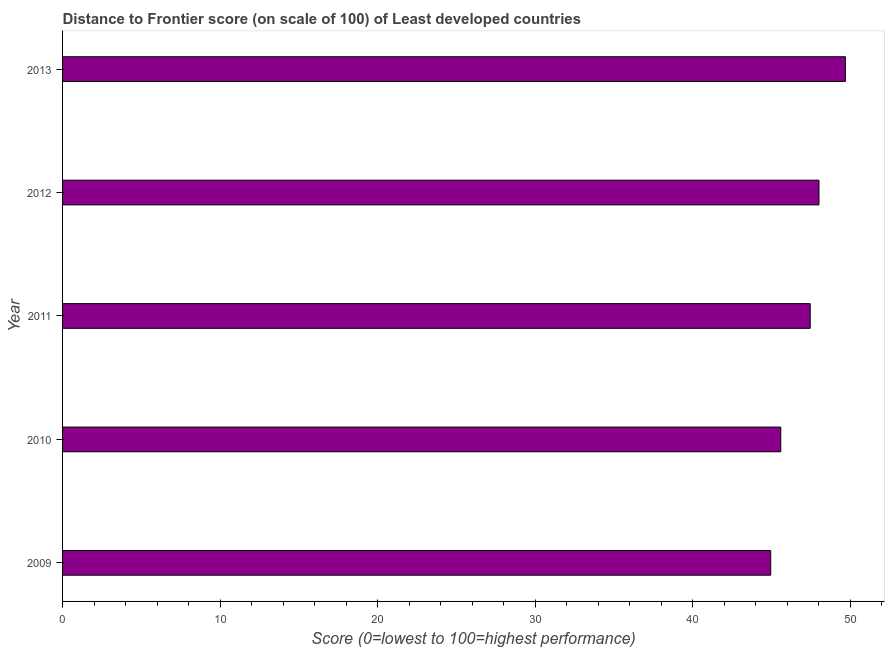Does the graph contain any zero values?
Your answer should be very brief. No. What is the title of the graph?
Offer a very short reply. Distance to Frontier score (on scale of 100) of Least developed countries. What is the label or title of the X-axis?
Your answer should be very brief. Score (0=lowest to 100=highest performance). What is the label or title of the Y-axis?
Keep it short and to the point. Year. What is the distance to frontier score in 2013?
Give a very brief answer. 49.7. Across all years, what is the maximum distance to frontier score?
Ensure brevity in your answer.  49.7. Across all years, what is the minimum distance to frontier score?
Your answer should be very brief. 44.96. In which year was the distance to frontier score maximum?
Provide a succinct answer. 2013. What is the sum of the distance to frontier score?
Your answer should be very brief. 235.77. What is the difference between the distance to frontier score in 2010 and 2011?
Make the answer very short. -1.87. What is the average distance to frontier score per year?
Give a very brief answer. 47.15. What is the median distance to frontier score?
Provide a succinct answer. 47.47. In how many years, is the distance to frontier score greater than 18 ?
Offer a very short reply. 5. Is the difference between the distance to frontier score in 2009 and 2012 greater than the difference between any two years?
Offer a very short reply. No. What is the difference between the highest and the second highest distance to frontier score?
Keep it short and to the point. 1.68. Is the sum of the distance to frontier score in 2010 and 2011 greater than the maximum distance to frontier score across all years?
Provide a succinct answer. Yes. What is the difference between the highest and the lowest distance to frontier score?
Offer a very short reply. 4.74. How many bars are there?
Provide a short and direct response. 5. Are all the bars in the graph horizontal?
Provide a succinct answer. Yes. How many years are there in the graph?
Your answer should be very brief. 5. What is the Score (0=lowest to 100=highest performance) of 2009?
Ensure brevity in your answer.  44.96. What is the Score (0=lowest to 100=highest performance) in 2010?
Your response must be concise. 45.6. What is the Score (0=lowest to 100=highest performance) of 2011?
Make the answer very short. 47.47. What is the Score (0=lowest to 100=highest performance) of 2012?
Provide a succinct answer. 48.03. What is the Score (0=lowest to 100=highest performance) of 2013?
Give a very brief answer. 49.7. What is the difference between the Score (0=lowest to 100=highest performance) in 2009 and 2010?
Keep it short and to the point. -0.64. What is the difference between the Score (0=lowest to 100=highest performance) in 2009 and 2011?
Give a very brief answer. -2.51. What is the difference between the Score (0=lowest to 100=highest performance) in 2009 and 2012?
Give a very brief answer. -3.06. What is the difference between the Score (0=lowest to 100=highest performance) in 2009 and 2013?
Offer a very short reply. -4.74. What is the difference between the Score (0=lowest to 100=highest performance) in 2010 and 2011?
Your answer should be very brief. -1.87. What is the difference between the Score (0=lowest to 100=highest performance) in 2010 and 2012?
Provide a short and direct response. -2.43. What is the difference between the Score (0=lowest to 100=highest performance) in 2010 and 2013?
Make the answer very short. -4.1. What is the difference between the Score (0=lowest to 100=highest performance) in 2011 and 2012?
Keep it short and to the point. -0.56. What is the difference between the Score (0=lowest to 100=highest performance) in 2011 and 2013?
Your answer should be compact. -2.23. What is the difference between the Score (0=lowest to 100=highest performance) in 2012 and 2013?
Give a very brief answer. -1.68. What is the ratio of the Score (0=lowest to 100=highest performance) in 2009 to that in 2011?
Offer a terse response. 0.95. What is the ratio of the Score (0=lowest to 100=highest performance) in 2009 to that in 2012?
Offer a terse response. 0.94. What is the ratio of the Score (0=lowest to 100=highest performance) in 2009 to that in 2013?
Provide a succinct answer. 0.91. What is the ratio of the Score (0=lowest to 100=highest performance) in 2010 to that in 2011?
Offer a terse response. 0.96. What is the ratio of the Score (0=lowest to 100=highest performance) in 2010 to that in 2012?
Provide a short and direct response. 0.95. What is the ratio of the Score (0=lowest to 100=highest performance) in 2010 to that in 2013?
Make the answer very short. 0.92. What is the ratio of the Score (0=lowest to 100=highest performance) in 2011 to that in 2012?
Offer a terse response. 0.99. What is the ratio of the Score (0=lowest to 100=highest performance) in 2011 to that in 2013?
Your response must be concise. 0.95. What is the ratio of the Score (0=lowest to 100=highest performance) in 2012 to that in 2013?
Give a very brief answer. 0.97. 